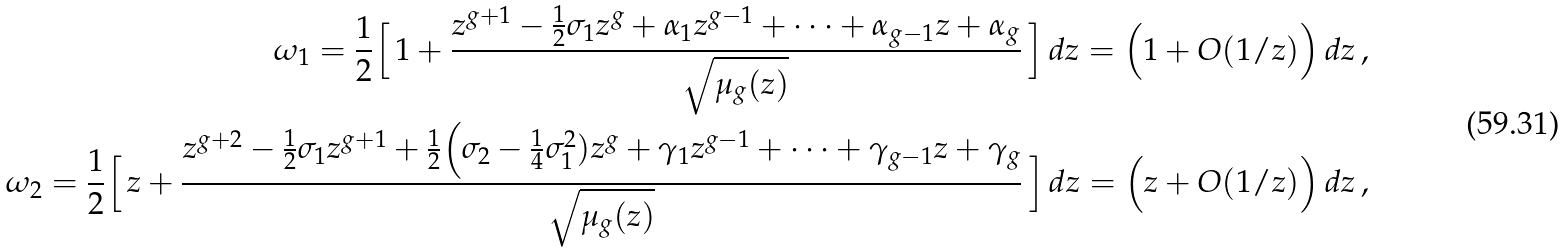Convert formula to latex. <formula><loc_0><loc_0><loc_500><loc_500>\omega _ { 1 } = \frac { 1 } { 2 } \Big [ \, 1 + \frac { z ^ { g + 1 } - \frac { 1 } { 2 } \sigma _ { 1 } z ^ { g } + \alpha _ { 1 } z ^ { g - 1 } + \cdots + \alpha _ { g - 1 } z + \alpha _ { g } } { \sqrt { \mu _ { g } ( z ) } } \, \Big ] \, d z = \Big ( 1 + O ( 1 / z ) \Big ) \, d z \, , \\ \omega _ { 2 } = \frac { 1 } { 2 } \Big [ \, z + \frac { z ^ { g + 2 } - \frac { 1 } { 2 } \sigma _ { 1 } z ^ { g + 1 } + \frac { 1 } { 2 } \Big ( \sigma _ { 2 } - \frac { 1 } { 4 } \sigma _ { 1 } ^ { 2 } ) z ^ { g } + \gamma _ { 1 } z ^ { g - 1 } + \cdots + \gamma _ { g - 1 } z + \gamma _ { g } } { \sqrt { \mu _ { g } ( z ) } } \, \Big ] \, d z = \Big ( z + O ( 1 / z ) \Big ) \, d z \, ,</formula> 